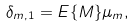<formula> <loc_0><loc_0><loc_500><loc_500>\delta _ { m , 1 } = E \{ M \} \mu _ { m } ,</formula> 